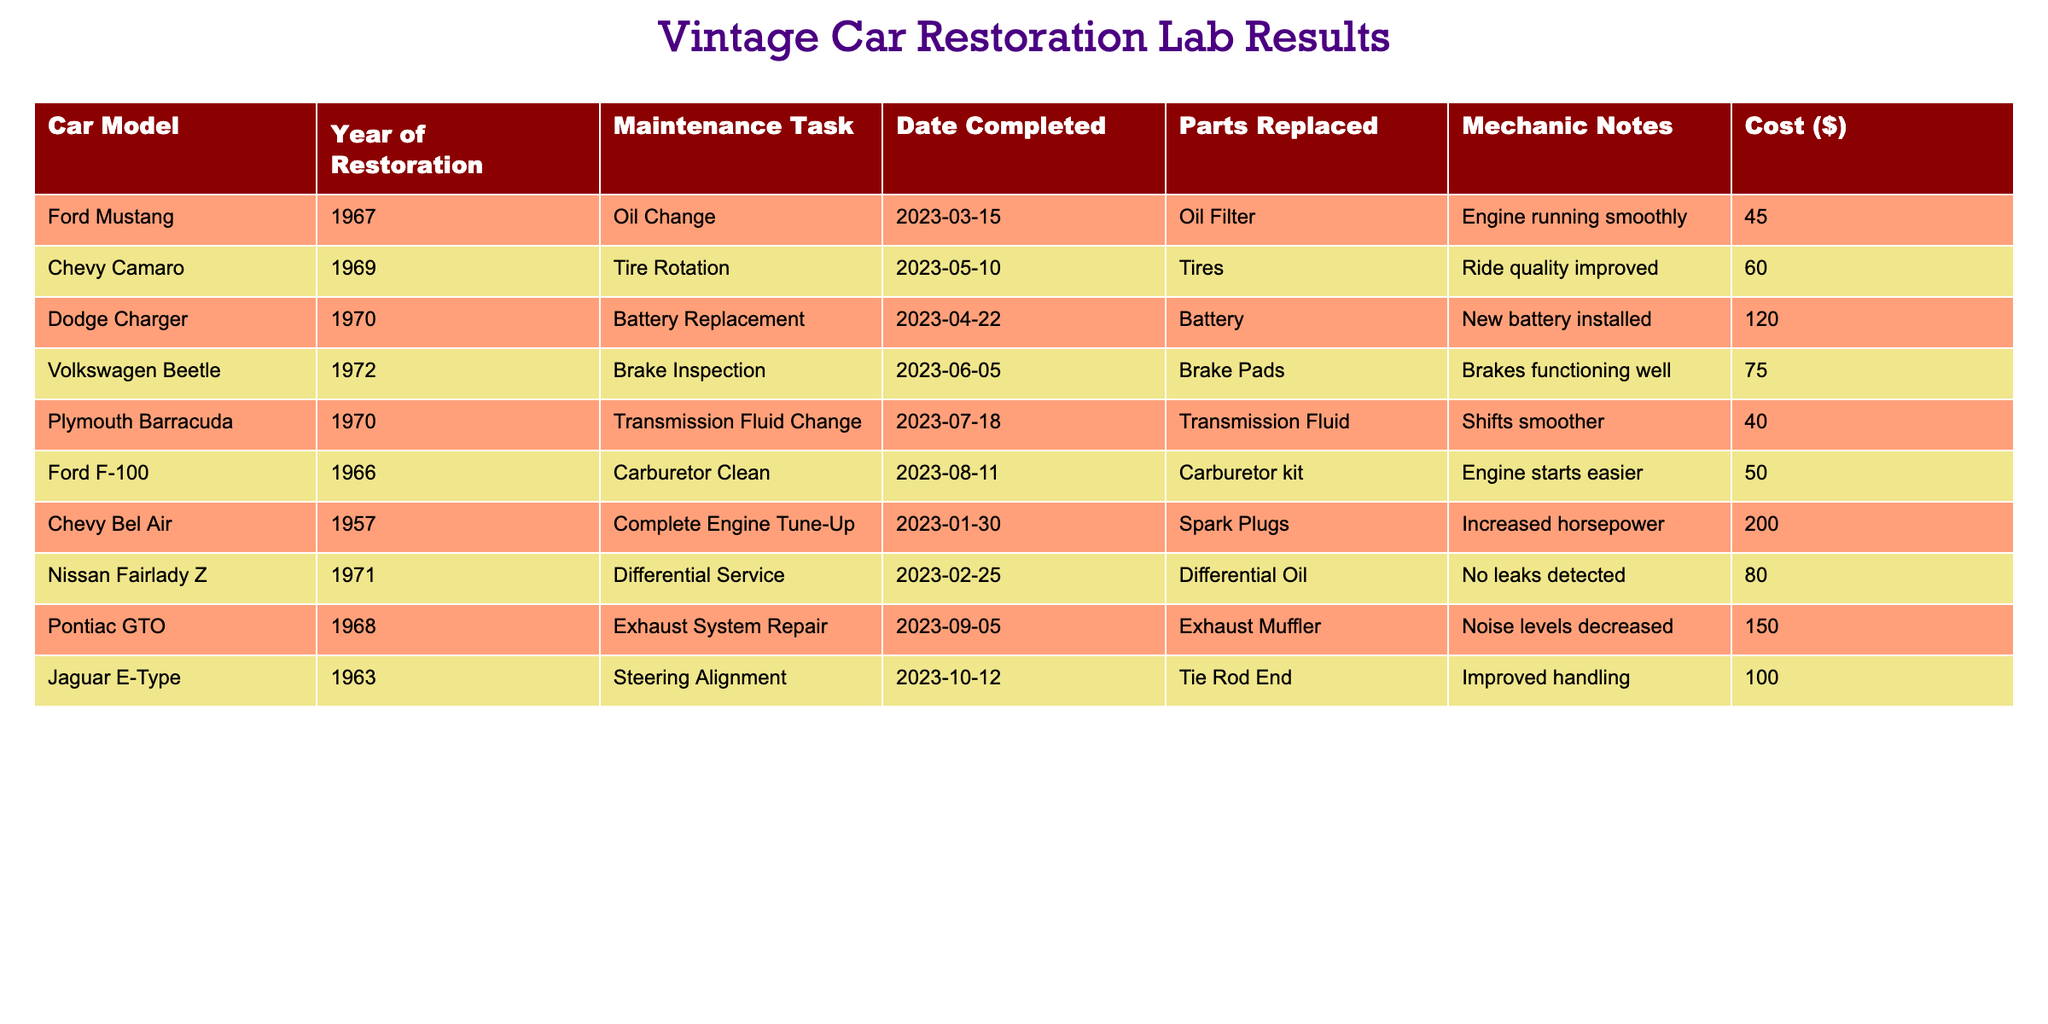What maintenance task was completed for the Dodge Charger? The table shows a row for the Dodge Charger that lists the maintenance task completed as "Battery Replacement." This can be directly found in the "Maintenance Task" column corresponding to the Dodge Charger in the "Car Model" column.
Answer: Battery Replacement Which car had the highest maintenance cost? By examining the "Cost ($)" column, the Chevy Bel Air has the highest cost at $200. This can be confirmed by comparing the values in the "Cost ($)" column for all cars.
Answer: Chevy Bel Air How many cars received maintenance in 2023? To find the number of cars that received maintenance in 2023, we can count the rows where the "Date Completed" indicates any date in that year. There are 8 maintenance tasks listed, all occurring in 2023.
Answer: 8 What was the average cost of maintenance for all cars? We can calculate the average cost by summing all the costs and dividing by the number of maintenance tasks. The total cost is 45 + 60 + 120 + 75 + 40 + 50 + 200 + 80 + 150 + 100 = 920. Since there are 10 cars, the average cost is 920/10 = 92.
Answer: 92 Did the Volkswagen Beetle have any parts replaced during its maintenance? Looking at the row for the Volkswagen Beetle, it shows "Brake Pads" listed in the "Parts Replaced" column. This confirms that the Volkswagen Beetle had parts replaced as part of its maintenance.
Answer: Yes What maintenance tasks were completed for cars that are older than 1970? To find the maintenance tasks for cars older than 1970, we look at the "Year of Restoration" column and identify those entries that are 1969 or earlier. The tasks for these cars are "Oil Change" for the Ford Mustang and "Complete Engine Tune-Up" for the Chevy Bel Air.
Answer: Oil Change and Complete Engine Tune-Up How many cars had their exhaust systems repaired? The table indicates that only the Pontiac GTO had an "Exhaust System Repair" performed. By looking through the "Maintenance Task" column, we can confirm there’s only one task listed under exhaust system repair.
Answer: 1 What mechanic notes were provided for the Plymouth Barracuda's maintenance? The mechanic notes for the Plymouth Barracuda, listed in the corresponding row, state, "Shifts smoother." This information is located in the "Mechanic Notes" column next to the Plymouth Barracuda entry.
Answer: Shifts smoother 